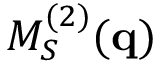Convert formula to latex. <formula><loc_0><loc_0><loc_500><loc_500>M _ { S } ^ { ( 2 ) } ( q )</formula> 